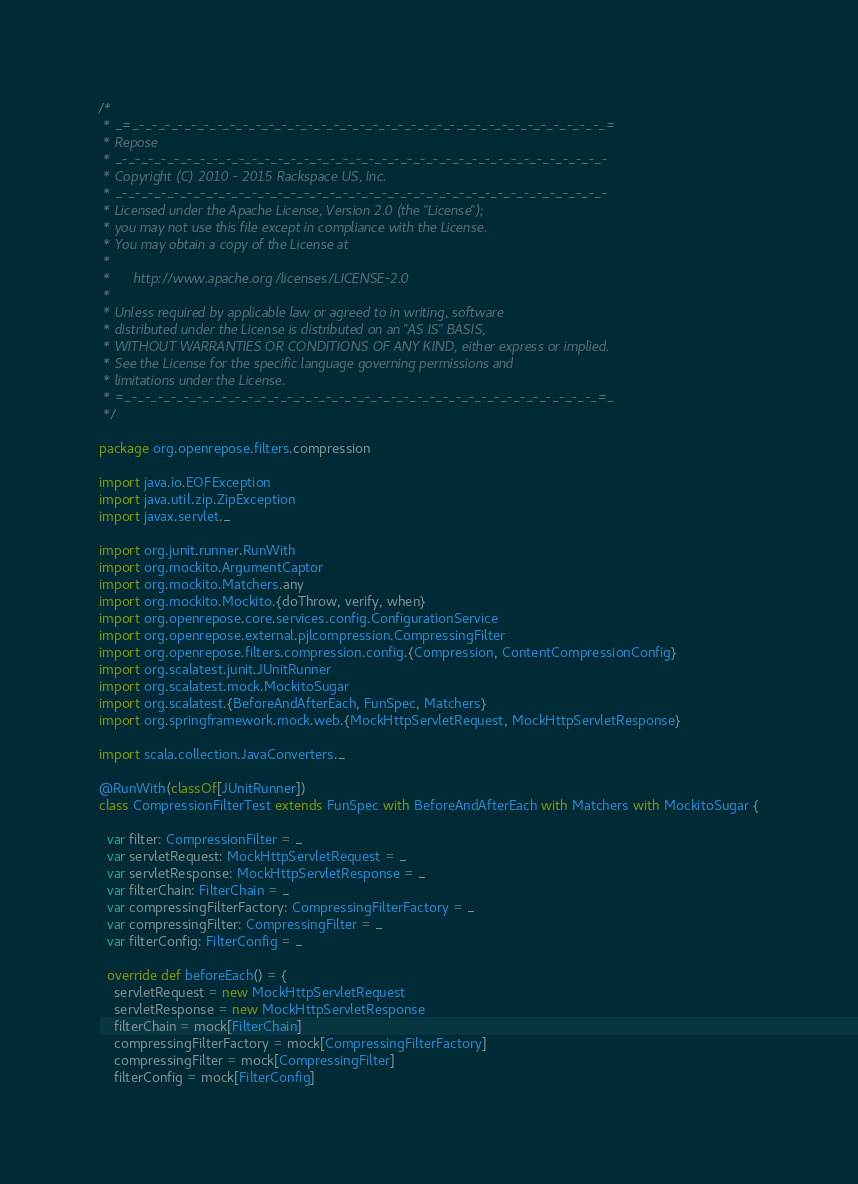Convert code to text. <code><loc_0><loc_0><loc_500><loc_500><_Scala_>/*
 * _=_-_-_-_-_-_-_-_-_-_-_-_-_-_-_-_-_-_-_-_-_-_-_-_-_-_-_-_-_-_-_-_-_-_-_-_-_=
 * Repose
 * _-_-_-_-_-_-_-_-_-_-_-_-_-_-_-_-_-_-_-_-_-_-_-_-_-_-_-_-_-_-_-_-_-_-_-_-_-_-
 * Copyright (C) 2010 - 2015 Rackspace US, Inc.
 * _-_-_-_-_-_-_-_-_-_-_-_-_-_-_-_-_-_-_-_-_-_-_-_-_-_-_-_-_-_-_-_-_-_-_-_-_-_-
 * Licensed under the Apache License, Version 2.0 (the "License");
 * you may not use this file except in compliance with the License.
 * You may obtain a copy of the License at
 *
 *      http://www.apache.org/licenses/LICENSE-2.0
 *
 * Unless required by applicable law or agreed to in writing, software
 * distributed under the License is distributed on an "AS IS" BASIS,
 * WITHOUT WARRANTIES OR CONDITIONS OF ANY KIND, either express or implied.
 * See the License for the specific language governing permissions and
 * limitations under the License.
 * =_-_-_-_-_-_-_-_-_-_-_-_-_-_-_-_-_-_-_-_-_-_-_-_-_-_-_-_-_-_-_-_-_-_-_-_-_=_
 */

package org.openrepose.filters.compression

import java.io.EOFException
import java.util.zip.ZipException
import javax.servlet._

import org.junit.runner.RunWith
import org.mockito.ArgumentCaptor
import org.mockito.Matchers.any
import org.mockito.Mockito.{doThrow, verify, when}
import org.openrepose.core.services.config.ConfigurationService
import org.openrepose.external.pjlcompression.CompressingFilter
import org.openrepose.filters.compression.config.{Compression, ContentCompressionConfig}
import org.scalatest.junit.JUnitRunner
import org.scalatest.mock.MockitoSugar
import org.scalatest.{BeforeAndAfterEach, FunSpec, Matchers}
import org.springframework.mock.web.{MockHttpServletRequest, MockHttpServletResponse}

import scala.collection.JavaConverters._

@RunWith(classOf[JUnitRunner])
class CompressionFilterTest extends FunSpec with BeforeAndAfterEach with Matchers with MockitoSugar {

  var filter: CompressionFilter = _
  var servletRequest: MockHttpServletRequest = _
  var servletResponse: MockHttpServletResponse = _
  var filterChain: FilterChain = _
  var compressingFilterFactory: CompressingFilterFactory = _
  var compressingFilter: CompressingFilter = _
  var filterConfig: FilterConfig = _

  override def beforeEach() = {
    servletRequest = new MockHttpServletRequest
    servletResponse = new MockHttpServletResponse
    filterChain = mock[FilterChain]
    compressingFilterFactory = mock[CompressingFilterFactory]
    compressingFilter = mock[CompressingFilter]
    filterConfig = mock[FilterConfig]
</code> 